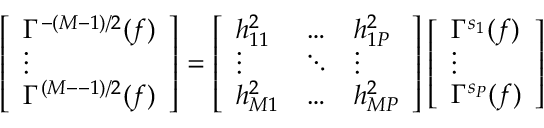<formula> <loc_0><loc_0><loc_500><loc_500>\left [ \begin{array} { l } { \Gamma ^ { - ( M { - } 1 ) / 2 } ( f ) } \\ { \vdots } \\ { \Gamma ^ { ( M { - } - 1 ) / 2 } ( f ) } \end{array} \right ] = \left [ \begin{array} { l l l } { h _ { 1 1 } ^ { 2 } } & { \hdots } & { h _ { 1 P } ^ { 2 } } \\ { \vdots } & { \ddots } & { \vdots } \\ { h _ { M 1 } ^ { 2 } } & { \hdots } & { h _ { M P } ^ { 2 } } \end{array} \right ] \left [ \begin{array} { l } { \Gamma ^ { s _ { 1 } } ( f ) } \\ { \vdots } \\ { \Gamma ^ { s _ { P } } ( f ) } \end{array} \right ]</formula> 